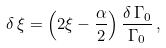<formula> <loc_0><loc_0><loc_500><loc_500>\delta \, \xi = \left ( 2 \xi - \frac { \alpha } { 2 } \right ) \frac { \delta \, \Gamma _ { 0 } } { \Gamma _ { 0 } } \, ,</formula> 